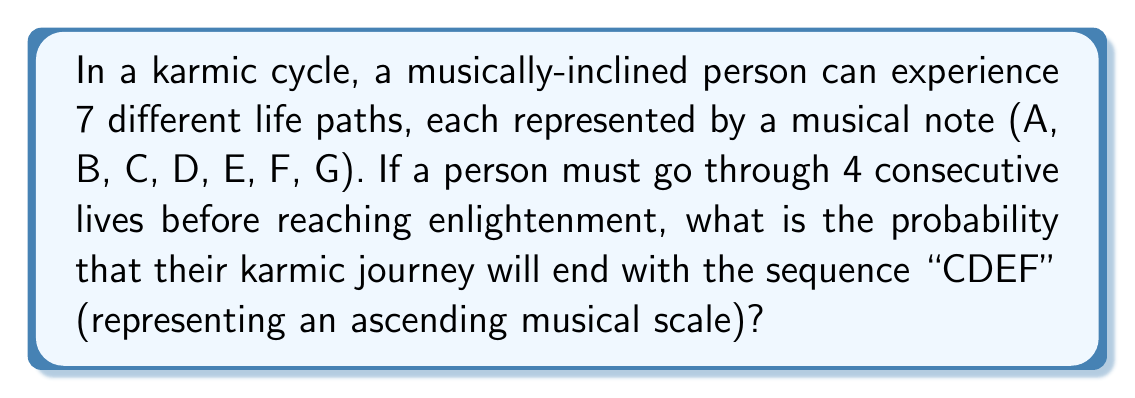Provide a solution to this math problem. To solve this problem, we need to use the concept of permutations and probability. Let's break it down step by step:

1. Total number of possible outcomes:
   We have 7 choices for each of the 4 lives, so the total number of possible outcomes is:
   
   $$7^4 = 2401$$

2. Number of favorable outcomes:
   We want the specific sequence "CDEF" to occur at the end of the 4 lives. This is only one possible outcome.

3. Probability calculation:
   The probability of a specific outcome is the number of favorable outcomes divided by the total number of possible outcomes:

   $$P(\text{CDEF}) = \frac{\text{Number of favorable outcomes}}{\text{Total number of possible outcomes}}$$

   $$P(\text{CDEF}) = \frac{1}{2401}$$

4. Simplifying the fraction:
   This fraction cannot be simplified further, as 2401 is a prime number.

Therefore, the probability of experiencing the karmic journey ending with the sequence "CDEF" is $\frac{1}{2401}$.
Answer: $\frac{1}{2401}$ 